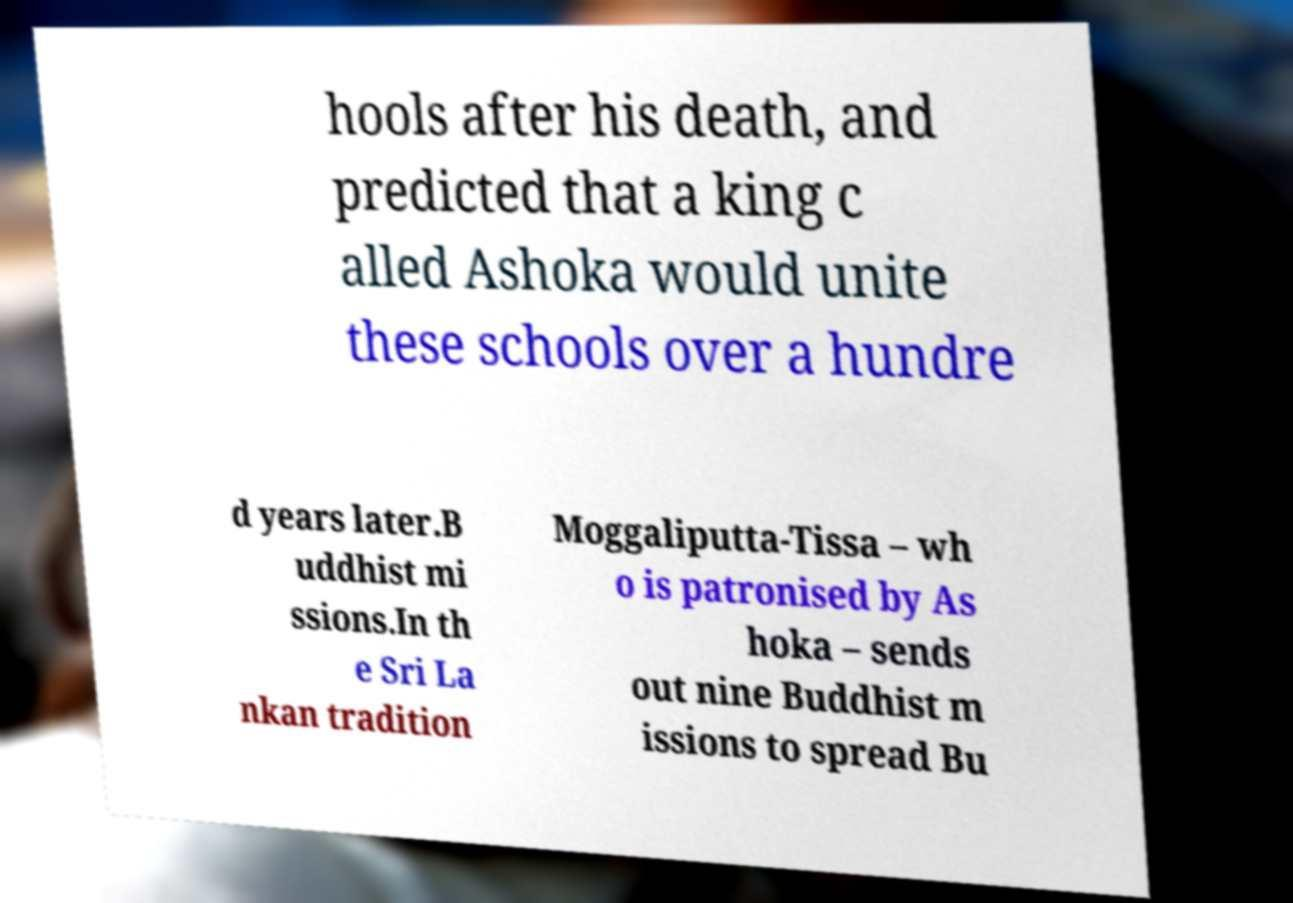Could you assist in decoding the text presented in this image and type it out clearly? hools after his death, and predicted that a king c alled Ashoka would unite these schools over a hundre d years later.B uddhist mi ssions.In th e Sri La nkan tradition Moggaliputta-Tissa – wh o is patronised by As hoka – sends out nine Buddhist m issions to spread Bu 